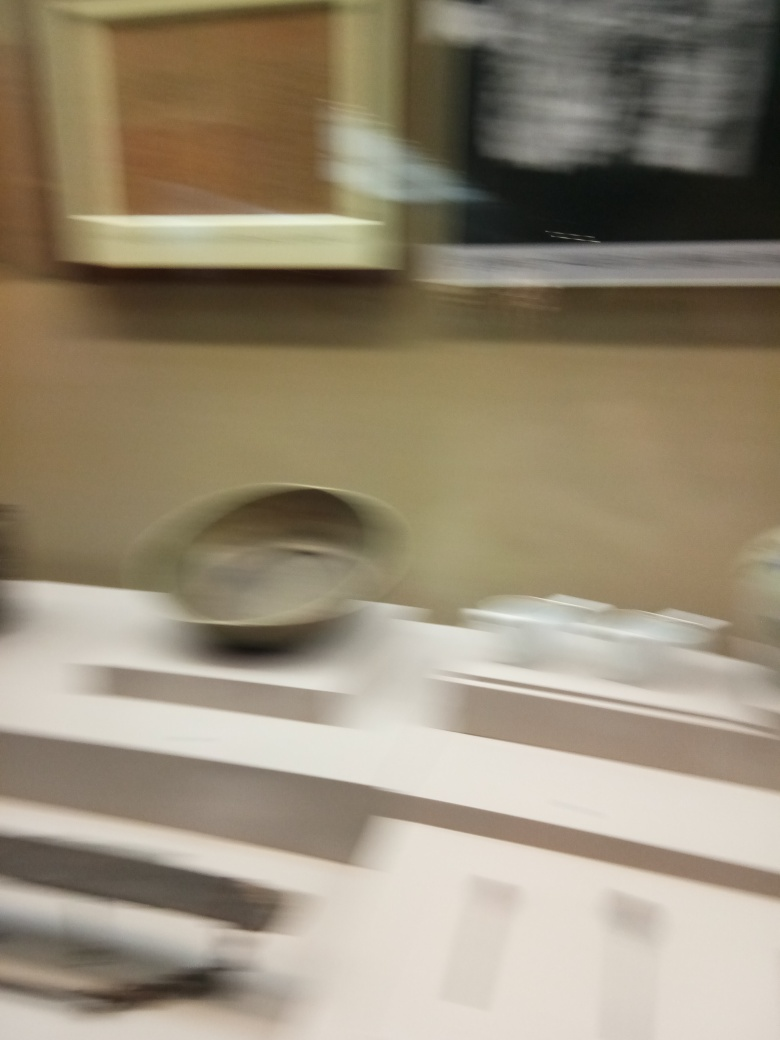Does the image have excessive noise? The image appears to have a significant amount of motion blur rather than noise, which usually manifests as grain or speckles. This blur could be due to camera movement or a long exposure time while the subjects were in motion. 